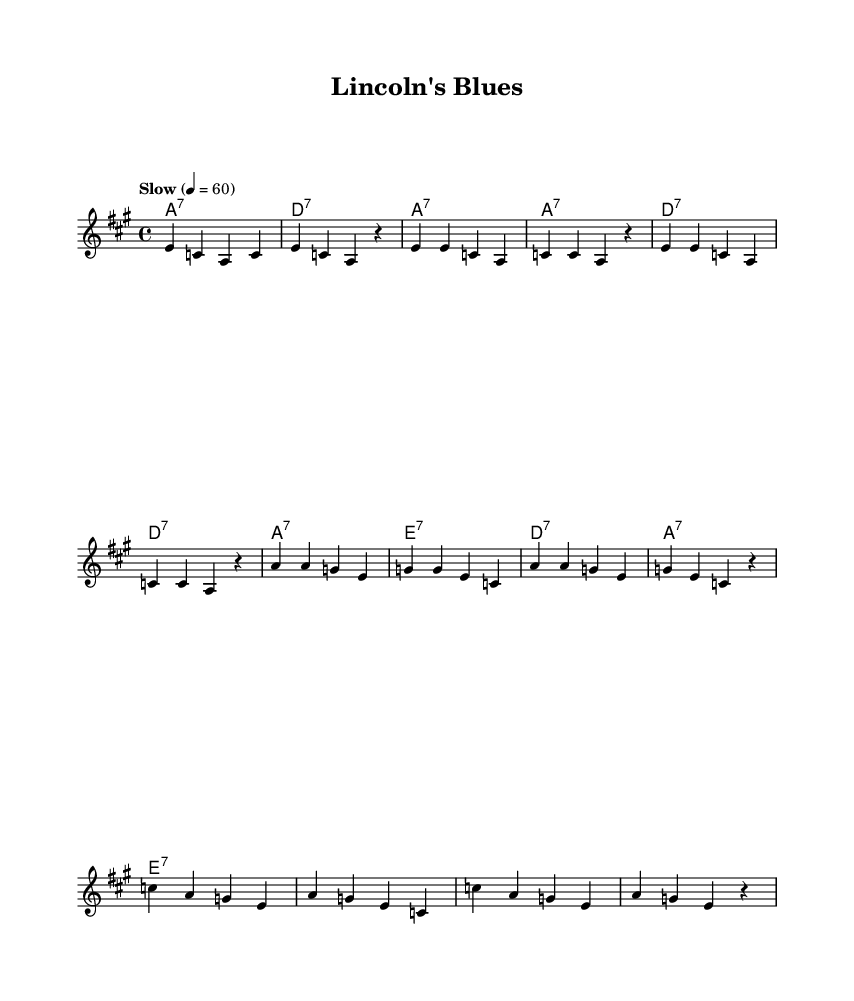What is the key signature of this music? The key signature indicates that there are three sharps, which signifies it is in the key of A major. This can be determined by looking at the music notation key signature section where the sharps are placed.
Answer: A major What is the time signature of this music? The time signature is identified at the beginning of the sheet music, showing a "4/4" marking, which means there are four beats in each measure and the quarter note gets one beat.
Answer: 4/4 What is the tempo marking of this music? The tempo marking is specified at the beginning with "Slow" and the tempo indicates a speed of 60 beats per minute. These details can be found written in the tempo section.
Answer: Slow How many verses are present in the song? By analyzing the lyrics section, there is one complete verse provided followed by a chorus and bridge. This is assessed by counting the distinct sections labeled in the lyrics.
Answer: One What is the first line of the verse? The verse begins with the lyrics "In eigh -- teen six -- ty -- five, a na -- tion torn a -- part." This can be found in the lyrics section under the verse marking.
Answer: In eigh -- teen six -- ty -- five, a na -- tion torn a -- part What type of chord is indicated for the first measure? The chord indicated for the first measure is A7, identified in the chord names section. One can confirm this by looking at the chord notations at the start of each measure in the harmonies.
Answer: A7 What historical figure is referenced in the song title? The title directly references Abraham Lincoln, as mentioned in both the title and the verses. This is identifiable from the lyrics in the context of the song discussing his impact.
Answer: Abraham Lincoln 